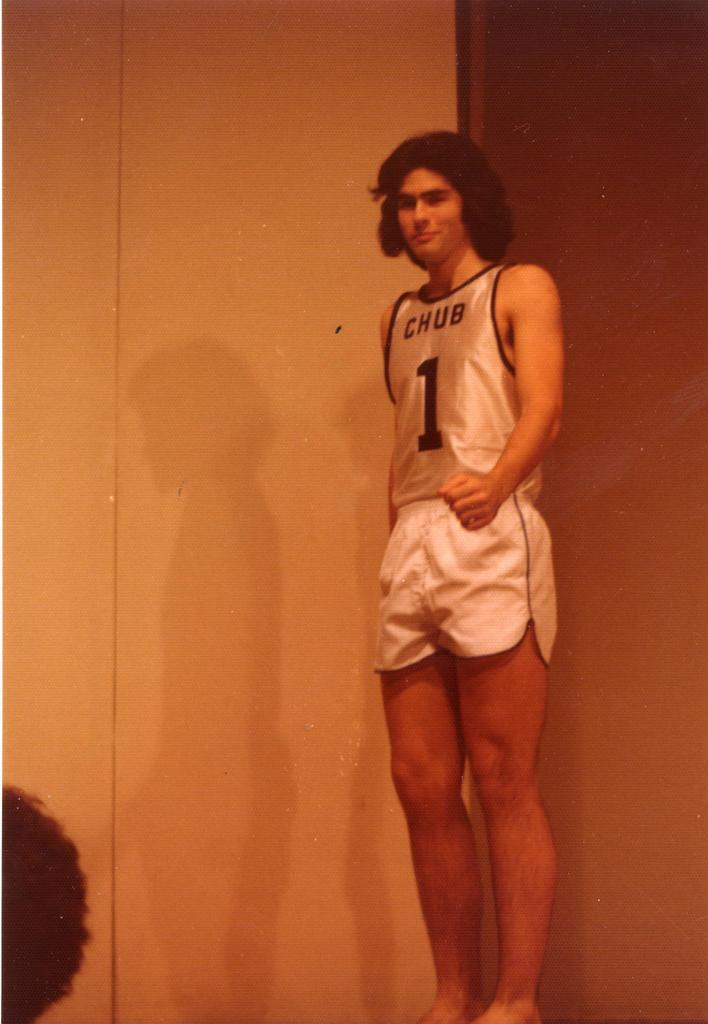<image>
Summarize the visual content of the image. a person with chub 1 on their jersey 